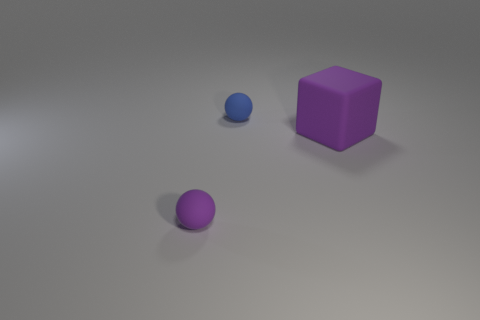Do the purple rubber thing that is left of the small blue sphere and the purple thing that is on the right side of the tiny blue rubber object have the same size?
Provide a short and direct response. No. There is a purple thing that is right of the small sphere that is on the left side of the blue matte ball; how big is it?
Provide a short and direct response. Large. The big rubber object is what color?
Make the answer very short. Purple. What is the shape of the thing that is left of the small blue ball?
Ensure brevity in your answer.  Sphere. There is a tiny object in front of the purple object that is on the right side of the blue matte object; is there a tiny purple matte thing behind it?
Make the answer very short. No. Is there anything else that is the same shape as the large object?
Your response must be concise. No. Is there a purple block?
Your response must be concise. Yes. How big is the purple object in front of the large rubber cube that is on the right side of the tiny matte object in front of the large rubber block?
Keep it short and to the point. Small. What number of yellow spheres are made of the same material as the small purple object?
Give a very brief answer. 0. Is the number of big cubes less than the number of tiny spheres?
Offer a very short reply. Yes. 